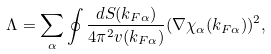Convert formula to latex. <formula><loc_0><loc_0><loc_500><loc_500>\Lambda = \sum _ { \alpha } \oint \frac { d S ( { k } _ { F \alpha } ) } { 4 \pi ^ { 2 } v ( { k } _ { F \alpha } ) } ( \nabla \chi _ { \alpha } ( { k } _ { F \alpha } ) ) ^ { 2 } ,</formula> 